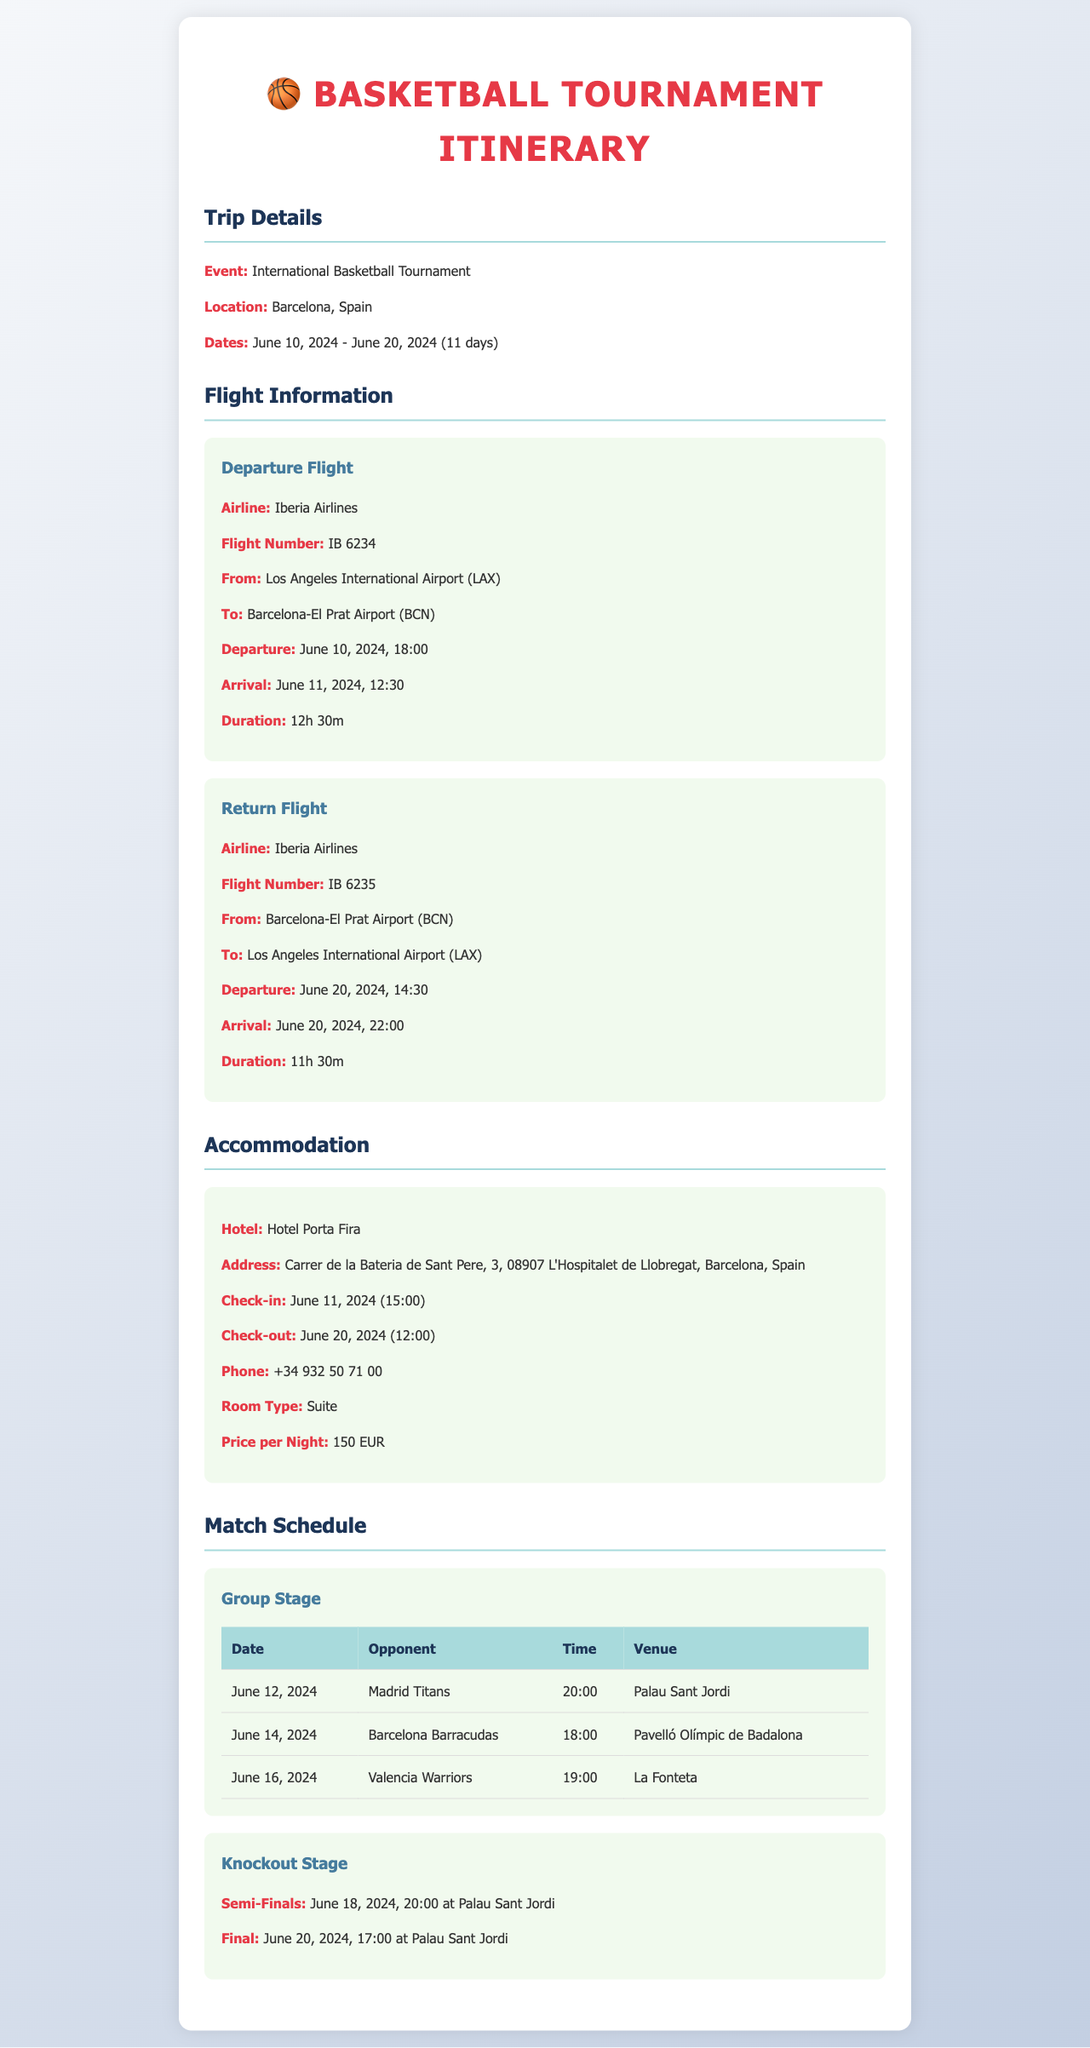What is the departure date for the flight? The departure date for the flight is mentioned in the flight details section as June 10, 2024.
Answer: June 10, 2024 What is the name of the hotel for accommodation? The name of the hotel is highlighted in the accommodation section as Hotel Porta Fira.
Answer: Hotel Porta Fira How long is the return flight duration? The return flight duration is provided in the flight details for the return flight as 11h 30m.
Answer: 11h 30m What is the time for the final match? The time for the final match is listed in the match details as 17:00.
Answer: 17:00 How many nights will the team stay in the hotel? The team will stay from June 11 to June 20, 2024, which accounts for 9 nights.
Answer: 9 nights What is the location of the tournament? The location of the tournament is specified in the trip details as Barcelona, Spain.
Answer: Barcelona, Spain What is the check-in time at the hotel? The check-in time at the hotel is stated as June 11, 2024, at 15:00.
Answer: 15:00 Which team is playing on June 14, 2024? The opponent team scheduled for June 14, 2024, is listed as Barcelona Barracudas.
Answer: Barcelona Barracudas What is the price per night for the accommodation? The price per night for the accommodation is highlighted in the accommodation section as 150 EUR.
Answer: 150 EUR 